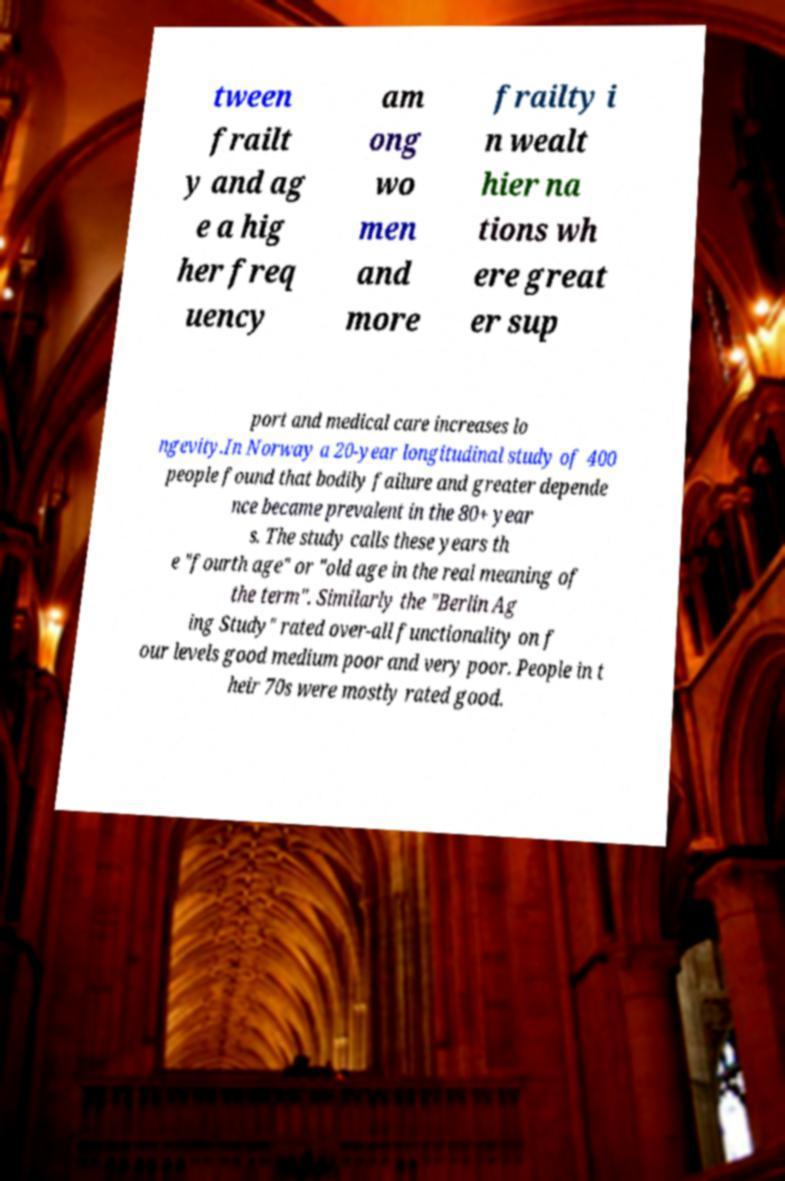For documentation purposes, I need the text within this image transcribed. Could you provide that? tween frailt y and ag e a hig her freq uency am ong wo men and more frailty i n wealt hier na tions wh ere great er sup port and medical care increases lo ngevity.In Norway a 20-year longitudinal study of 400 people found that bodily failure and greater depende nce became prevalent in the 80+ year s. The study calls these years th e "fourth age" or "old age in the real meaning of the term". Similarly the "Berlin Ag ing Study" rated over-all functionality on f our levels good medium poor and very poor. People in t heir 70s were mostly rated good. 